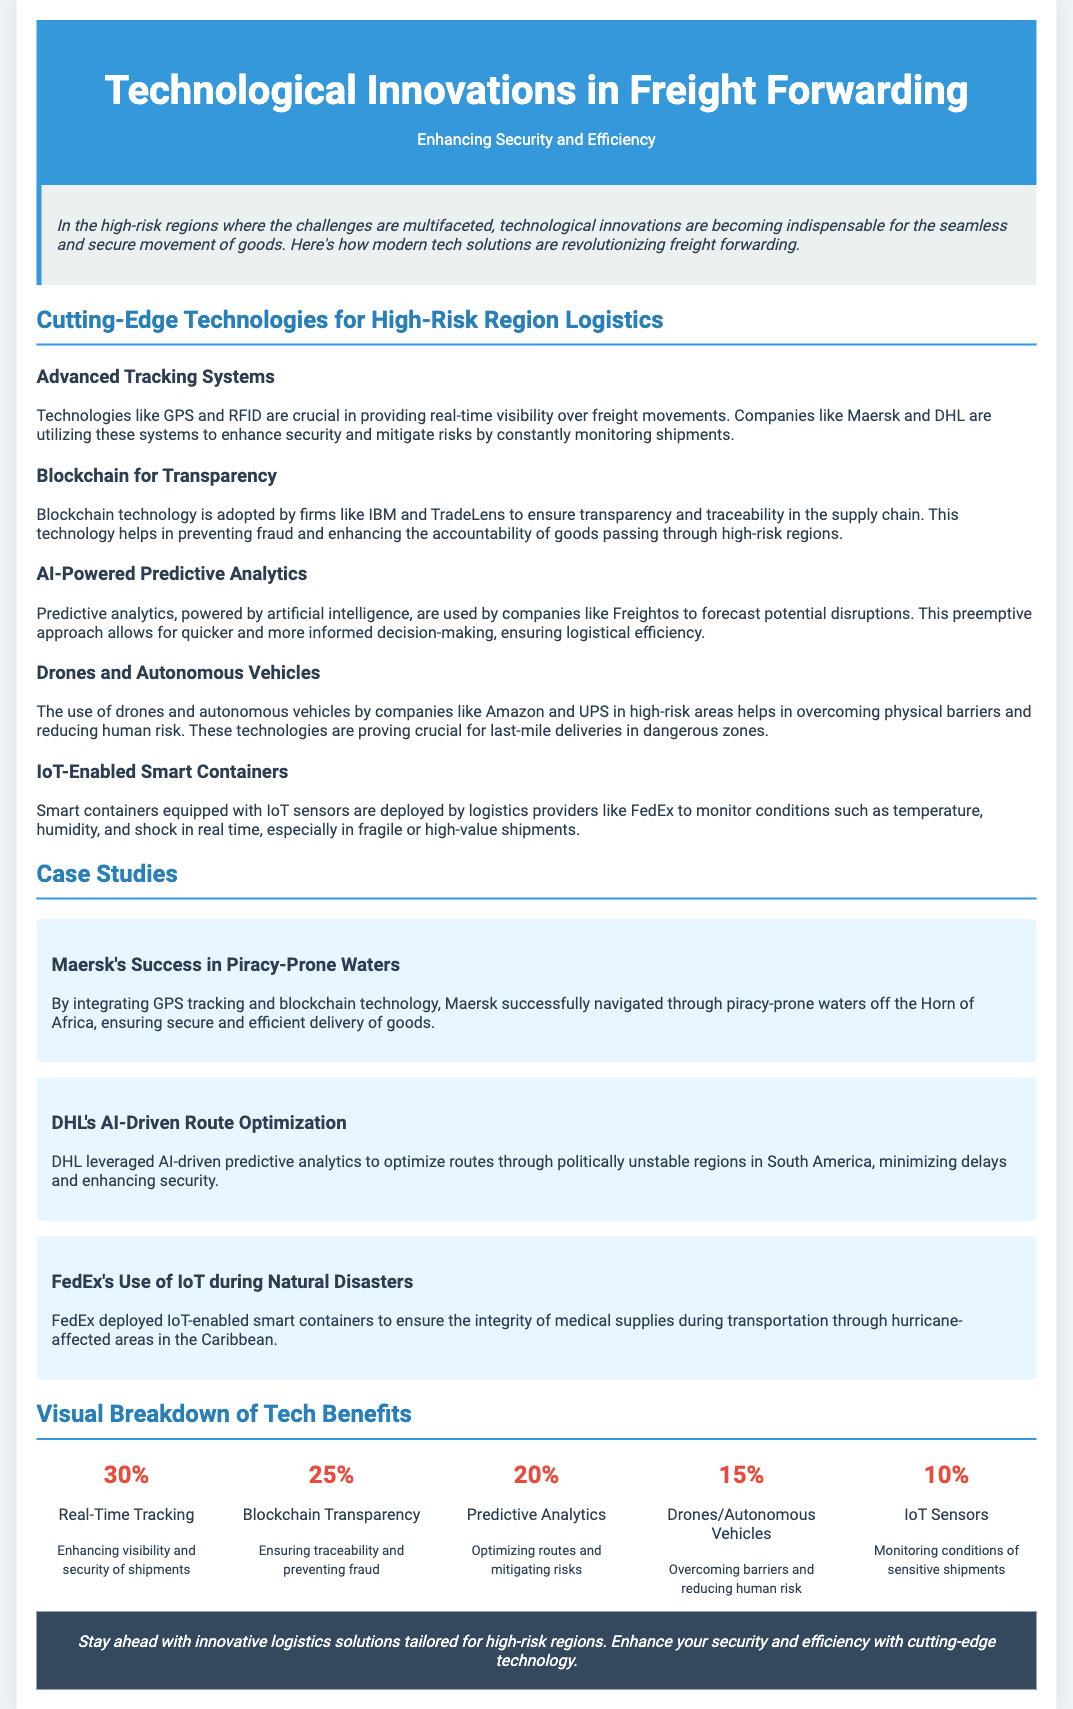What is the title of the flyer? The title is mentioned prominently at the top of the flyer, indicating the main topic.
Answer: Technological Innovations in Freight Forwarding What percentage of benefits corresponds to Real-Time Tracking? This percentage is displayed in the visual breakdown section of the flyer.
Answer: 30% Which company successfully navigated piracy-prone waters? This information is provided in the case studies section of the flyer.
Answer: Maersk What technological solution does DHL use for route optimization? The specific technology is mentioned in the context of a real-world example in the document.
Answer: AI-Driven Predictive Analytics What is the main emphasis of the introduction? This captures the general theme highlighted in the summary section of the flyer.
Answer: The importance of technological innovations for secure goods movement What are IoT sensors used to monitor? This is detailed in the section discussing IoT-enabled smart containers.
Answer: Conditions of sensitive shipments What is one key benefit of using Drones/Autonomous Vehicles? This information is provided in the visual breakdown of tech benefits.
Answer: Overcoming barriers and reducing human risk What technology prevents fraud in the supply chain? This technology is referenced in the section dedicated to blockchain.
Answer: Blockchain What company deployed IoT-enabled smart containers during natural disasters? The document mentions specific examples in its case studies section.
Answer: FedEx 